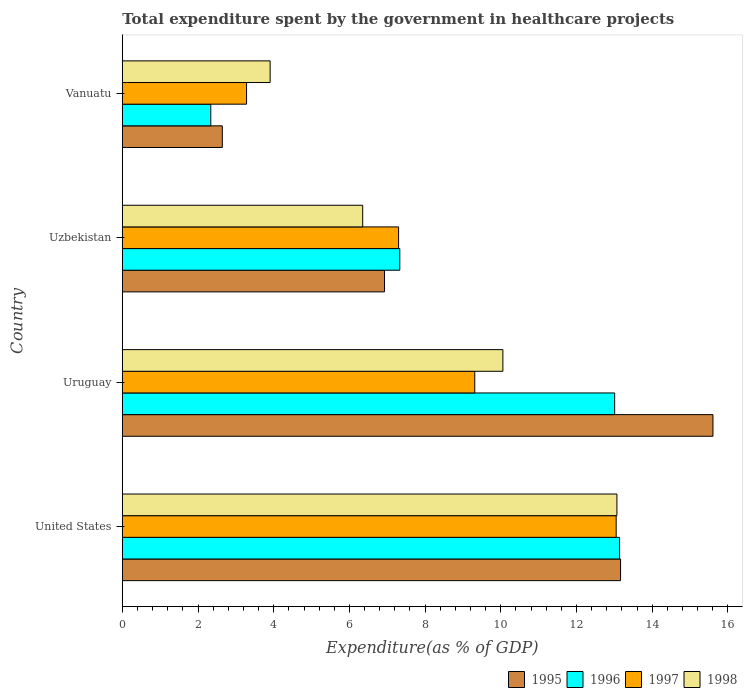How many different coloured bars are there?
Provide a succinct answer. 4. Are the number of bars per tick equal to the number of legend labels?
Keep it short and to the point. Yes. How many bars are there on the 1st tick from the bottom?
Ensure brevity in your answer.  4. What is the label of the 1st group of bars from the top?
Offer a very short reply. Vanuatu. In how many cases, is the number of bars for a given country not equal to the number of legend labels?
Keep it short and to the point. 0. What is the total expenditure spent by the government in healthcare projects in 1995 in Vanuatu?
Your answer should be compact. 2.64. Across all countries, what is the maximum total expenditure spent by the government in healthcare projects in 1997?
Offer a very short reply. 13.05. Across all countries, what is the minimum total expenditure spent by the government in healthcare projects in 1997?
Make the answer very short. 3.28. In which country was the total expenditure spent by the government in healthcare projects in 1997 maximum?
Make the answer very short. United States. In which country was the total expenditure spent by the government in healthcare projects in 1997 minimum?
Offer a terse response. Vanuatu. What is the total total expenditure spent by the government in healthcare projects in 1997 in the graph?
Your answer should be compact. 32.94. What is the difference between the total expenditure spent by the government in healthcare projects in 1998 in Uzbekistan and that in Vanuatu?
Ensure brevity in your answer.  2.45. What is the difference between the total expenditure spent by the government in healthcare projects in 1995 in Vanuatu and the total expenditure spent by the government in healthcare projects in 1996 in Uruguay?
Give a very brief answer. -10.36. What is the average total expenditure spent by the government in healthcare projects in 1997 per country?
Offer a very short reply. 8.23. What is the difference between the total expenditure spent by the government in healthcare projects in 1996 and total expenditure spent by the government in healthcare projects in 1995 in United States?
Provide a succinct answer. -0.03. What is the ratio of the total expenditure spent by the government in healthcare projects in 1995 in Uzbekistan to that in Vanuatu?
Offer a terse response. 2.62. Is the total expenditure spent by the government in healthcare projects in 1995 in United States less than that in Uruguay?
Make the answer very short. Yes. Is the difference between the total expenditure spent by the government in healthcare projects in 1996 in United States and Vanuatu greater than the difference between the total expenditure spent by the government in healthcare projects in 1995 in United States and Vanuatu?
Provide a succinct answer. Yes. What is the difference between the highest and the second highest total expenditure spent by the government in healthcare projects in 1996?
Your answer should be very brief. 0.13. What is the difference between the highest and the lowest total expenditure spent by the government in healthcare projects in 1998?
Provide a succinct answer. 9.16. Is it the case that in every country, the sum of the total expenditure spent by the government in healthcare projects in 1998 and total expenditure spent by the government in healthcare projects in 1997 is greater than the sum of total expenditure spent by the government in healthcare projects in 1996 and total expenditure spent by the government in healthcare projects in 1995?
Keep it short and to the point. No. What does the 1st bar from the top in United States represents?
Offer a terse response. 1998. Is it the case that in every country, the sum of the total expenditure spent by the government in healthcare projects in 1995 and total expenditure spent by the government in healthcare projects in 1996 is greater than the total expenditure spent by the government in healthcare projects in 1998?
Keep it short and to the point. Yes. How many countries are there in the graph?
Make the answer very short. 4. What is the difference between two consecutive major ticks on the X-axis?
Provide a succinct answer. 2. Are the values on the major ticks of X-axis written in scientific E-notation?
Offer a very short reply. No. Does the graph contain any zero values?
Ensure brevity in your answer.  No. Where does the legend appear in the graph?
Your answer should be very brief. Bottom right. How are the legend labels stacked?
Ensure brevity in your answer.  Horizontal. What is the title of the graph?
Offer a terse response. Total expenditure spent by the government in healthcare projects. Does "1990" appear as one of the legend labels in the graph?
Make the answer very short. No. What is the label or title of the X-axis?
Offer a terse response. Expenditure(as % of GDP). What is the label or title of the Y-axis?
Your answer should be very brief. Country. What is the Expenditure(as % of GDP) of 1995 in United States?
Offer a terse response. 13.16. What is the Expenditure(as % of GDP) of 1996 in United States?
Provide a succinct answer. 13.14. What is the Expenditure(as % of GDP) of 1997 in United States?
Your answer should be compact. 13.05. What is the Expenditure(as % of GDP) of 1998 in United States?
Your response must be concise. 13.07. What is the Expenditure(as % of GDP) of 1995 in Uruguay?
Ensure brevity in your answer.  15.6. What is the Expenditure(as % of GDP) of 1996 in Uruguay?
Your answer should be very brief. 13.01. What is the Expenditure(as % of GDP) in 1997 in Uruguay?
Make the answer very short. 9.31. What is the Expenditure(as % of GDP) in 1998 in Uruguay?
Ensure brevity in your answer.  10.05. What is the Expenditure(as % of GDP) of 1995 in Uzbekistan?
Offer a terse response. 6.93. What is the Expenditure(as % of GDP) of 1996 in Uzbekistan?
Your answer should be very brief. 7.33. What is the Expenditure(as % of GDP) of 1997 in Uzbekistan?
Provide a short and direct response. 7.3. What is the Expenditure(as % of GDP) of 1998 in Uzbekistan?
Your response must be concise. 6.35. What is the Expenditure(as % of GDP) in 1995 in Vanuatu?
Offer a very short reply. 2.64. What is the Expenditure(as % of GDP) in 1996 in Vanuatu?
Make the answer very short. 2.34. What is the Expenditure(as % of GDP) of 1997 in Vanuatu?
Keep it short and to the point. 3.28. What is the Expenditure(as % of GDP) in 1998 in Vanuatu?
Ensure brevity in your answer.  3.91. Across all countries, what is the maximum Expenditure(as % of GDP) of 1995?
Your answer should be very brief. 15.6. Across all countries, what is the maximum Expenditure(as % of GDP) in 1996?
Your answer should be compact. 13.14. Across all countries, what is the maximum Expenditure(as % of GDP) of 1997?
Make the answer very short. 13.05. Across all countries, what is the maximum Expenditure(as % of GDP) in 1998?
Keep it short and to the point. 13.07. Across all countries, what is the minimum Expenditure(as % of GDP) in 1995?
Provide a succinct answer. 2.64. Across all countries, what is the minimum Expenditure(as % of GDP) of 1996?
Offer a terse response. 2.34. Across all countries, what is the minimum Expenditure(as % of GDP) of 1997?
Your answer should be very brief. 3.28. Across all countries, what is the minimum Expenditure(as % of GDP) of 1998?
Offer a terse response. 3.91. What is the total Expenditure(as % of GDP) in 1995 in the graph?
Your answer should be very brief. 38.33. What is the total Expenditure(as % of GDP) in 1996 in the graph?
Ensure brevity in your answer.  35.81. What is the total Expenditure(as % of GDP) in 1997 in the graph?
Provide a short and direct response. 32.94. What is the total Expenditure(as % of GDP) of 1998 in the graph?
Your response must be concise. 33.38. What is the difference between the Expenditure(as % of GDP) of 1995 in United States and that in Uruguay?
Give a very brief answer. -2.44. What is the difference between the Expenditure(as % of GDP) in 1996 in United States and that in Uruguay?
Keep it short and to the point. 0.13. What is the difference between the Expenditure(as % of GDP) of 1997 in United States and that in Uruguay?
Your response must be concise. 3.73. What is the difference between the Expenditure(as % of GDP) of 1998 in United States and that in Uruguay?
Your answer should be compact. 3.01. What is the difference between the Expenditure(as % of GDP) of 1995 in United States and that in Uzbekistan?
Provide a succinct answer. 6.24. What is the difference between the Expenditure(as % of GDP) of 1996 in United States and that in Uzbekistan?
Offer a terse response. 5.81. What is the difference between the Expenditure(as % of GDP) of 1997 in United States and that in Uzbekistan?
Your answer should be compact. 5.75. What is the difference between the Expenditure(as % of GDP) of 1998 in United States and that in Uzbekistan?
Provide a succinct answer. 6.72. What is the difference between the Expenditure(as % of GDP) of 1995 in United States and that in Vanuatu?
Ensure brevity in your answer.  10.52. What is the difference between the Expenditure(as % of GDP) in 1996 in United States and that in Vanuatu?
Give a very brief answer. 10.8. What is the difference between the Expenditure(as % of GDP) of 1997 in United States and that in Vanuatu?
Your answer should be compact. 9.76. What is the difference between the Expenditure(as % of GDP) in 1998 in United States and that in Vanuatu?
Offer a very short reply. 9.16. What is the difference between the Expenditure(as % of GDP) of 1995 in Uruguay and that in Uzbekistan?
Provide a succinct answer. 8.68. What is the difference between the Expenditure(as % of GDP) in 1996 in Uruguay and that in Uzbekistan?
Your answer should be compact. 5.68. What is the difference between the Expenditure(as % of GDP) in 1997 in Uruguay and that in Uzbekistan?
Give a very brief answer. 2.01. What is the difference between the Expenditure(as % of GDP) in 1998 in Uruguay and that in Uzbekistan?
Your response must be concise. 3.7. What is the difference between the Expenditure(as % of GDP) in 1995 in Uruguay and that in Vanuatu?
Give a very brief answer. 12.96. What is the difference between the Expenditure(as % of GDP) of 1996 in Uruguay and that in Vanuatu?
Your answer should be compact. 10.67. What is the difference between the Expenditure(as % of GDP) in 1997 in Uruguay and that in Vanuatu?
Offer a terse response. 6.03. What is the difference between the Expenditure(as % of GDP) in 1998 in Uruguay and that in Vanuatu?
Your response must be concise. 6.15. What is the difference between the Expenditure(as % of GDP) in 1995 in Uzbekistan and that in Vanuatu?
Keep it short and to the point. 4.28. What is the difference between the Expenditure(as % of GDP) of 1996 in Uzbekistan and that in Vanuatu?
Your answer should be compact. 4.99. What is the difference between the Expenditure(as % of GDP) in 1997 in Uzbekistan and that in Vanuatu?
Provide a short and direct response. 4.02. What is the difference between the Expenditure(as % of GDP) of 1998 in Uzbekistan and that in Vanuatu?
Give a very brief answer. 2.45. What is the difference between the Expenditure(as % of GDP) in 1995 in United States and the Expenditure(as % of GDP) in 1996 in Uruguay?
Your answer should be very brief. 0.16. What is the difference between the Expenditure(as % of GDP) in 1995 in United States and the Expenditure(as % of GDP) in 1997 in Uruguay?
Ensure brevity in your answer.  3.85. What is the difference between the Expenditure(as % of GDP) of 1995 in United States and the Expenditure(as % of GDP) of 1998 in Uruguay?
Offer a terse response. 3.11. What is the difference between the Expenditure(as % of GDP) in 1996 in United States and the Expenditure(as % of GDP) in 1997 in Uruguay?
Your answer should be compact. 3.83. What is the difference between the Expenditure(as % of GDP) in 1996 in United States and the Expenditure(as % of GDP) in 1998 in Uruguay?
Offer a terse response. 3.08. What is the difference between the Expenditure(as % of GDP) in 1997 in United States and the Expenditure(as % of GDP) in 1998 in Uruguay?
Provide a short and direct response. 2.99. What is the difference between the Expenditure(as % of GDP) in 1995 in United States and the Expenditure(as % of GDP) in 1996 in Uzbekistan?
Your answer should be very brief. 5.83. What is the difference between the Expenditure(as % of GDP) in 1995 in United States and the Expenditure(as % of GDP) in 1997 in Uzbekistan?
Your answer should be very brief. 5.86. What is the difference between the Expenditure(as % of GDP) in 1995 in United States and the Expenditure(as % of GDP) in 1998 in Uzbekistan?
Give a very brief answer. 6.81. What is the difference between the Expenditure(as % of GDP) in 1996 in United States and the Expenditure(as % of GDP) in 1997 in Uzbekistan?
Your answer should be very brief. 5.84. What is the difference between the Expenditure(as % of GDP) of 1996 in United States and the Expenditure(as % of GDP) of 1998 in Uzbekistan?
Your answer should be very brief. 6.79. What is the difference between the Expenditure(as % of GDP) of 1997 in United States and the Expenditure(as % of GDP) of 1998 in Uzbekistan?
Your answer should be compact. 6.7. What is the difference between the Expenditure(as % of GDP) in 1995 in United States and the Expenditure(as % of GDP) in 1996 in Vanuatu?
Give a very brief answer. 10.82. What is the difference between the Expenditure(as % of GDP) of 1995 in United States and the Expenditure(as % of GDP) of 1997 in Vanuatu?
Provide a succinct answer. 9.88. What is the difference between the Expenditure(as % of GDP) in 1995 in United States and the Expenditure(as % of GDP) in 1998 in Vanuatu?
Ensure brevity in your answer.  9.26. What is the difference between the Expenditure(as % of GDP) in 1996 in United States and the Expenditure(as % of GDP) in 1997 in Vanuatu?
Give a very brief answer. 9.85. What is the difference between the Expenditure(as % of GDP) in 1996 in United States and the Expenditure(as % of GDP) in 1998 in Vanuatu?
Your answer should be very brief. 9.23. What is the difference between the Expenditure(as % of GDP) in 1997 in United States and the Expenditure(as % of GDP) in 1998 in Vanuatu?
Ensure brevity in your answer.  9.14. What is the difference between the Expenditure(as % of GDP) in 1995 in Uruguay and the Expenditure(as % of GDP) in 1996 in Uzbekistan?
Offer a terse response. 8.27. What is the difference between the Expenditure(as % of GDP) in 1995 in Uruguay and the Expenditure(as % of GDP) in 1997 in Uzbekistan?
Your response must be concise. 8.3. What is the difference between the Expenditure(as % of GDP) of 1995 in Uruguay and the Expenditure(as % of GDP) of 1998 in Uzbekistan?
Provide a succinct answer. 9.25. What is the difference between the Expenditure(as % of GDP) in 1996 in Uruguay and the Expenditure(as % of GDP) in 1997 in Uzbekistan?
Give a very brief answer. 5.71. What is the difference between the Expenditure(as % of GDP) of 1996 in Uruguay and the Expenditure(as % of GDP) of 1998 in Uzbekistan?
Keep it short and to the point. 6.66. What is the difference between the Expenditure(as % of GDP) of 1997 in Uruguay and the Expenditure(as % of GDP) of 1998 in Uzbekistan?
Ensure brevity in your answer.  2.96. What is the difference between the Expenditure(as % of GDP) in 1995 in Uruguay and the Expenditure(as % of GDP) in 1996 in Vanuatu?
Offer a terse response. 13.27. What is the difference between the Expenditure(as % of GDP) of 1995 in Uruguay and the Expenditure(as % of GDP) of 1997 in Vanuatu?
Offer a very short reply. 12.32. What is the difference between the Expenditure(as % of GDP) of 1995 in Uruguay and the Expenditure(as % of GDP) of 1998 in Vanuatu?
Keep it short and to the point. 11.7. What is the difference between the Expenditure(as % of GDP) in 1996 in Uruguay and the Expenditure(as % of GDP) in 1997 in Vanuatu?
Give a very brief answer. 9.72. What is the difference between the Expenditure(as % of GDP) in 1996 in Uruguay and the Expenditure(as % of GDP) in 1998 in Vanuatu?
Your answer should be compact. 9.1. What is the difference between the Expenditure(as % of GDP) of 1997 in Uruguay and the Expenditure(as % of GDP) of 1998 in Vanuatu?
Give a very brief answer. 5.41. What is the difference between the Expenditure(as % of GDP) in 1995 in Uzbekistan and the Expenditure(as % of GDP) in 1996 in Vanuatu?
Provide a short and direct response. 4.59. What is the difference between the Expenditure(as % of GDP) in 1995 in Uzbekistan and the Expenditure(as % of GDP) in 1997 in Vanuatu?
Provide a short and direct response. 3.64. What is the difference between the Expenditure(as % of GDP) of 1995 in Uzbekistan and the Expenditure(as % of GDP) of 1998 in Vanuatu?
Offer a terse response. 3.02. What is the difference between the Expenditure(as % of GDP) in 1996 in Uzbekistan and the Expenditure(as % of GDP) in 1997 in Vanuatu?
Ensure brevity in your answer.  4.05. What is the difference between the Expenditure(as % of GDP) in 1996 in Uzbekistan and the Expenditure(as % of GDP) in 1998 in Vanuatu?
Your answer should be compact. 3.43. What is the difference between the Expenditure(as % of GDP) in 1997 in Uzbekistan and the Expenditure(as % of GDP) in 1998 in Vanuatu?
Give a very brief answer. 3.39. What is the average Expenditure(as % of GDP) of 1995 per country?
Your answer should be very brief. 9.58. What is the average Expenditure(as % of GDP) in 1996 per country?
Your answer should be very brief. 8.95. What is the average Expenditure(as % of GDP) of 1997 per country?
Offer a terse response. 8.23. What is the average Expenditure(as % of GDP) of 1998 per country?
Provide a succinct answer. 8.34. What is the difference between the Expenditure(as % of GDP) in 1995 and Expenditure(as % of GDP) in 1996 in United States?
Offer a terse response. 0.03. What is the difference between the Expenditure(as % of GDP) in 1995 and Expenditure(as % of GDP) in 1997 in United States?
Provide a succinct answer. 0.12. What is the difference between the Expenditure(as % of GDP) in 1995 and Expenditure(as % of GDP) in 1998 in United States?
Offer a terse response. 0.1. What is the difference between the Expenditure(as % of GDP) in 1996 and Expenditure(as % of GDP) in 1997 in United States?
Your answer should be very brief. 0.09. What is the difference between the Expenditure(as % of GDP) of 1996 and Expenditure(as % of GDP) of 1998 in United States?
Make the answer very short. 0.07. What is the difference between the Expenditure(as % of GDP) of 1997 and Expenditure(as % of GDP) of 1998 in United States?
Your answer should be very brief. -0.02. What is the difference between the Expenditure(as % of GDP) of 1995 and Expenditure(as % of GDP) of 1996 in Uruguay?
Offer a very short reply. 2.6. What is the difference between the Expenditure(as % of GDP) in 1995 and Expenditure(as % of GDP) in 1997 in Uruguay?
Keep it short and to the point. 6.29. What is the difference between the Expenditure(as % of GDP) of 1995 and Expenditure(as % of GDP) of 1998 in Uruguay?
Offer a terse response. 5.55. What is the difference between the Expenditure(as % of GDP) in 1996 and Expenditure(as % of GDP) in 1997 in Uruguay?
Make the answer very short. 3.69. What is the difference between the Expenditure(as % of GDP) in 1996 and Expenditure(as % of GDP) in 1998 in Uruguay?
Keep it short and to the point. 2.95. What is the difference between the Expenditure(as % of GDP) in 1997 and Expenditure(as % of GDP) in 1998 in Uruguay?
Provide a short and direct response. -0.74. What is the difference between the Expenditure(as % of GDP) of 1995 and Expenditure(as % of GDP) of 1996 in Uzbekistan?
Give a very brief answer. -0.4. What is the difference between the Expenditure(as % of GDP) in 1995 and Expenditure(as % of GDP) in 1997 in Uzbekistan?
Your answer should be compact. -0.37. What is the difference between the Expenditure(as % of GDP) of 1995 and Expenditure(as % of GDP) of 1998 in Uzbekistan?
Provide a succinct answer. 0.58. What is the difference between the Expenditure(as % of GDP) of 1996 and Expenditure(as % of GDP) of 1997 in Uzbekistan?
Ensure brevity in your answer.  0.03. What is the difference between the Expenditure(as % of GDP) of 1996 and Expenditure(as % of GDP) of 1998 in Uzbekistan?
Offer a terse response. 0.98. What is the difference between the Expenditure(as % of GDP) of 1997 and Expenditure(as % of GDP) of 1998 in Uzbekistan?
Your answer should be compact. 0.95. What is the difference between the Expenditure(as % of GDP) in 1995 and Expenditure(as % of GDP) in 1996 in Vanuatu?
Provide a succinct answer. 0.3. What is the difference between the Expenditure(as % of GDP) in 1995 and Expenditure(as % of GDP) in 1997 in Vanuatu?
Make the answer very short. -0.64. What is the difference between the Expenditure(as % of GDP) in 1995 and Expenditure(as % of GDP) in 1998 in Vanuatu?
Make the answer very short. -1.26. What is the difference between the Expenditure(as % of GDP) in 1996 and Expenditure(as % of GDP) in 1997 in Vanuatu?
Your answer should be very brief. -0.94. What is the difference between the Expenditure(as % of GDP) in 1996 and Expenditure(as % of GDP) in 1998 in Vanuatu?
Offer a terse response. -1.57. What is the difference between the Expenditure(as % of GDP) of 1997 and Expenditure(as % of GDP) of 1998 in Vanuatu?
Give a very brief answer. -0.62. What is the ratio of the Expenditure(as % of GDP) in 1995 in United States to that in Uruguay?
Your response must be concise. 0.84. What is the ratio of the Expenditure(as % of GDP) of 1997 in United States to that in Uruguay?
Offer a terse response. 1.4. What is the ratio of the Expenditure(as % of GDP) in 1998 in United States to that in Uruguay?
Make the answer very short. 1.3. What is the ratio of the Expenditure(as % of GDP) of 1995 in United States to that in Uzbekistan?
Provide a short and direct response. 1.9. What is the ratio of the Expenditure(as % of GDP) in 1996 in United States to that in Uzbekistan?
Make the answer very short. 1.79. What is the ratio of the Expenditure(as % of GDP) of 1997 in United States to that in Uzbekistan?
Your answer should be very brief. 1.79. What is the ratio of the Expenditure(as % of GDP) in 1998 in United States to that in Uzbekistan?
Offer a terse response. 2.06. What is the ratio of the Expenditure(as % of GDP) in 1995 in United States to that in Vanuatu?
Provide a succinct answer. 4.98. What is the ratio of the Expenditure(as % of GDP) of 1996 in United States to that in Vanuatu?
Offer a very short reply. 5.62. What is the ratio of the Expenditure(as % of GDP) of 1997 in United States to that in Vanuatu?
Offer a terse response. 3.97. What is the ratio of the Expenditure(as % of GDP) in 1998 in United States to that in Vanuatu?
Offer a very short reply. 3.35. What is the ratio of the Expenditure(as % of GDP) of 1995 in Uruguay to that in Uzbekistan?
Your response must be concise. 2.25. What is the ratio of the Expenditure(as % of GDP) in 1996 in Uruguay to that in Uzbekistan?
Your response must be concise. 1.77. What is the ratio of the Expenditure(as % of GDP) in 1997 in Uruguay to that in Uzbekistan?
Provide a short and direct response. 1.28. What is the ratio of the Expenditure(as % of GDP) of 1998 in Uruguay to that in Uzbekistan?
Offer a terse response. 1.58. What is the ratio of the Expenditure(as % of GDP) in 1995 in Uruguay to that in Vanuatu?
Keep it short and to the point. 5.91. What is the ratio of the Expenditure(as % of GDP) in 1996 in Uruguay to that in Vanuatu?
Keep it short and to the point. 5.56. What is the ratio of the Expenditure(as % of GDP) in 1997 in Uruguay to that in Vanuatu?
Offer a terse response. 2.84. What is the ratio of the Expenditure(as % of GDP) in 1998 in Uruguay to that in Vanuatu?
Keep it short and to the point. 2.57. What is the ratio of the Expenditure(as % of GDP) in 1995 in Uzbekistan to that in Vanuatu?
Your response must be concise. 2.62. What is the ratio of the Expenditure(as % of GDP) of 1996 in Uzbekistan to that in Vanuatu?
Your response must be concise. 3.14. What is the ratio of the Expenditure(as % of GDP) of 1997 in Uzbekistan to that in Vanuatu?
Give a very brief answer. 2.22. What is the ratio of the Expenditure(as % of GDP) of 1998 in Uzbekistan to that in Vanuatu?
Your answer should be compact. 1.63. What is the difference between the highest and the second highest Expenditure(as % of GDP) in 1995?
Provide a succinct answer. 2.44. What is the difference between the highest and the second highest Expenditure(as % of GDP) of 1996?
Provide a succinct answer. 0.13. What is the difference between the highest and the second highest Expenditure(as % of GDP) in 1997?
Offer a very short reply. 3.73. What is the difference between the highest and the second highest Expenditure(as % of GDP) of 1998?
Your answer should be compact. 3.01. What is the difference between the highest and the lowest Expenditure(as % of GDP) in 1995?
Give a very brief answer. 12.96. What is the difference between the highest and the lowest Expenditure(as % of GDP) in 1996?
Your response must be concise. 10.8. What is the difference between the highest and the lowest Expenditure(as % of GDP) of 1997?
Provide a short and direct response. 9.76. What is the difference between the highest and the lowest Expenditure(as % of GDP) in 1998?
Offer a very short reply. 9.16. 